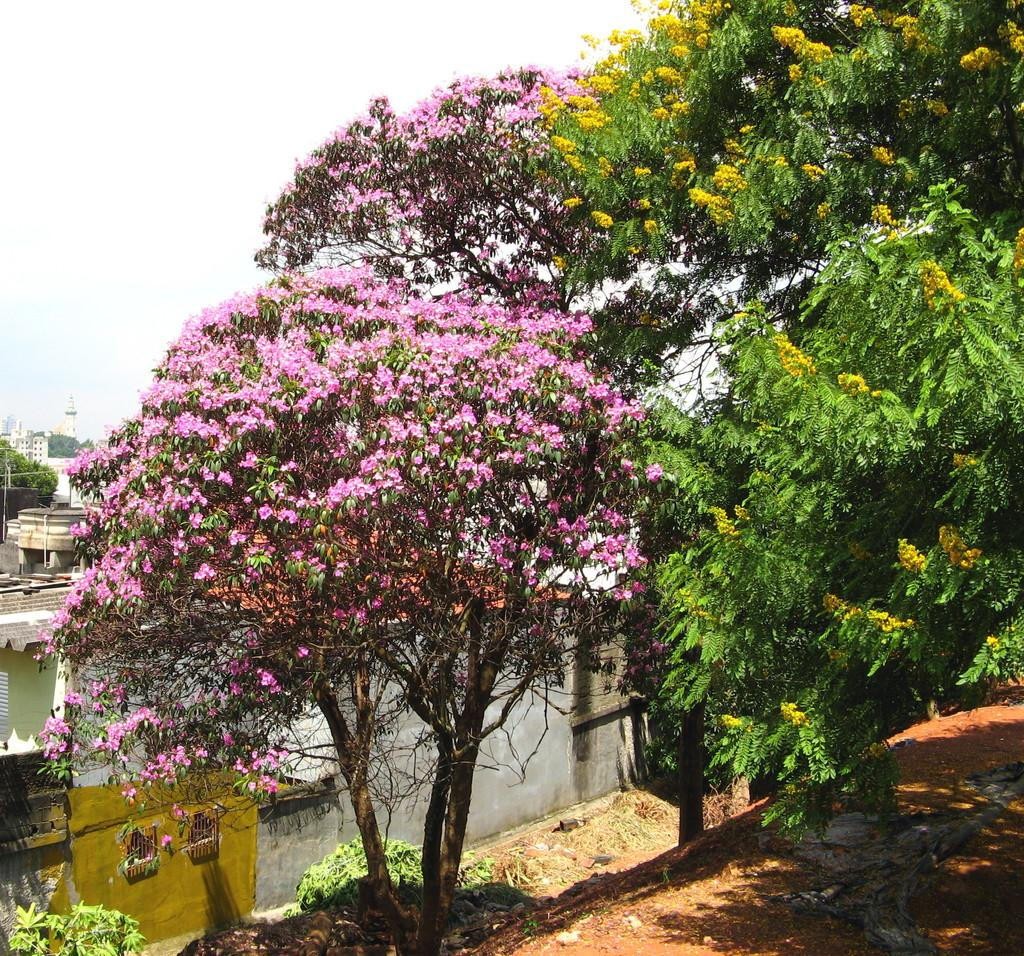What type of plants can be seen in the image? There are flowers and trees in the image. What type of structures are present in the image? There are buildings in the image. What type of orange is hanging from the tree in the image? There is no orange present in the image; it features flowers, trees, and buildings. What material is the crib made of in the image? There is no crib present in the image. 